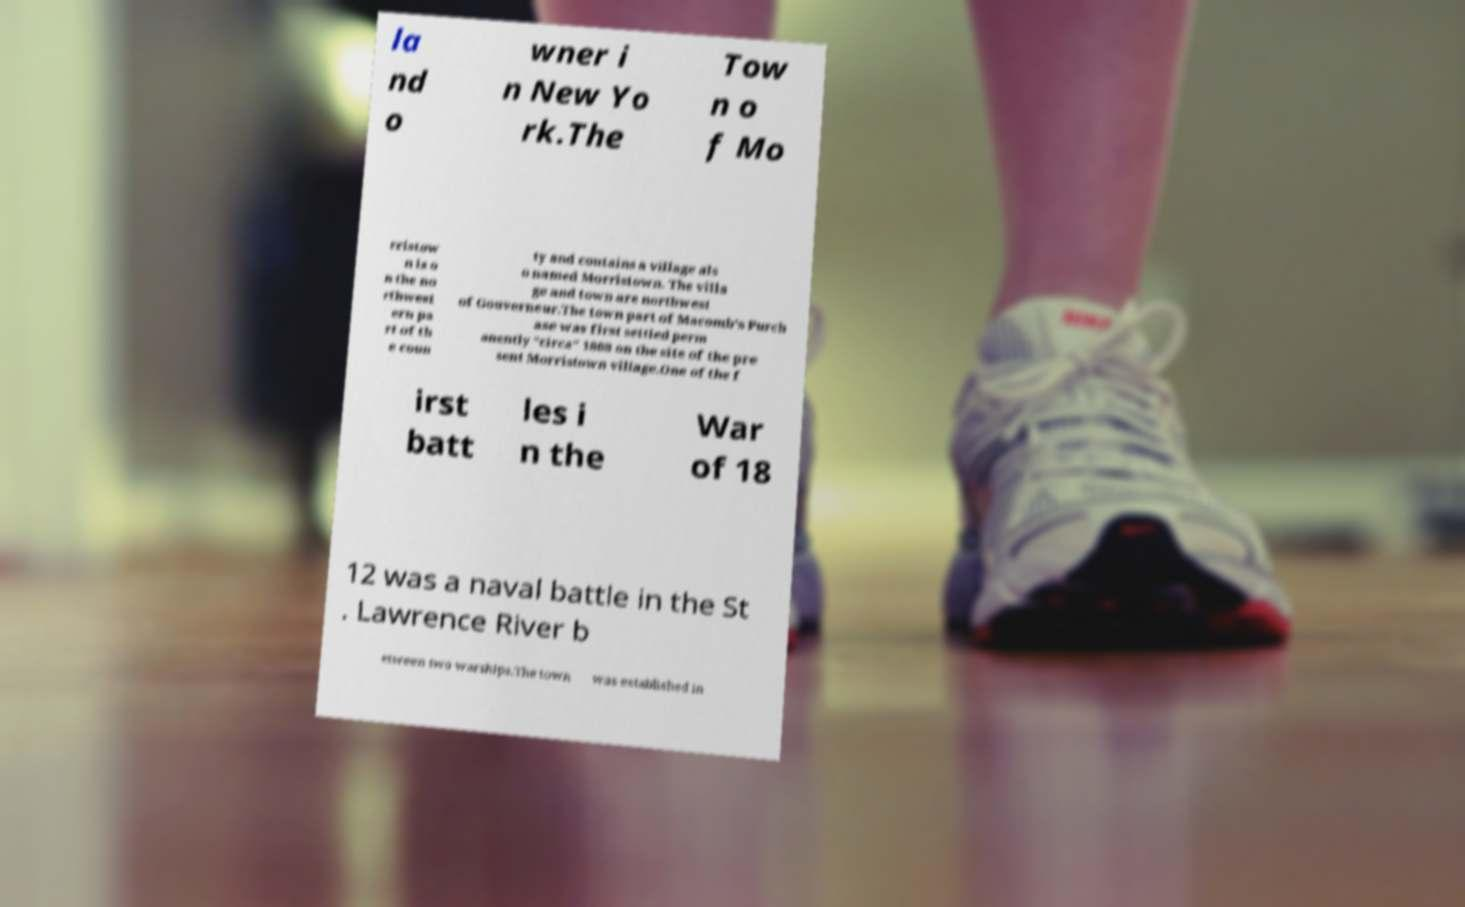Please identify and transcribe the text found in this image. la nd o wner i n New Yo rk.The Tow n o f Mo rristow n is o n the no rthwest ern pa rt of th e coun ty and contains a village als o named Morristown. The villa ge and town are northwest of Gouverneur.The town part of Macomb's Purch ase was first settled perm anently "circa" 1808 on the site of the pre sent Morristown village.One of the f irst batt les i n the War of 18 12 was a naval battle in the St . Lawrence River b etween two warships.The town was established in 